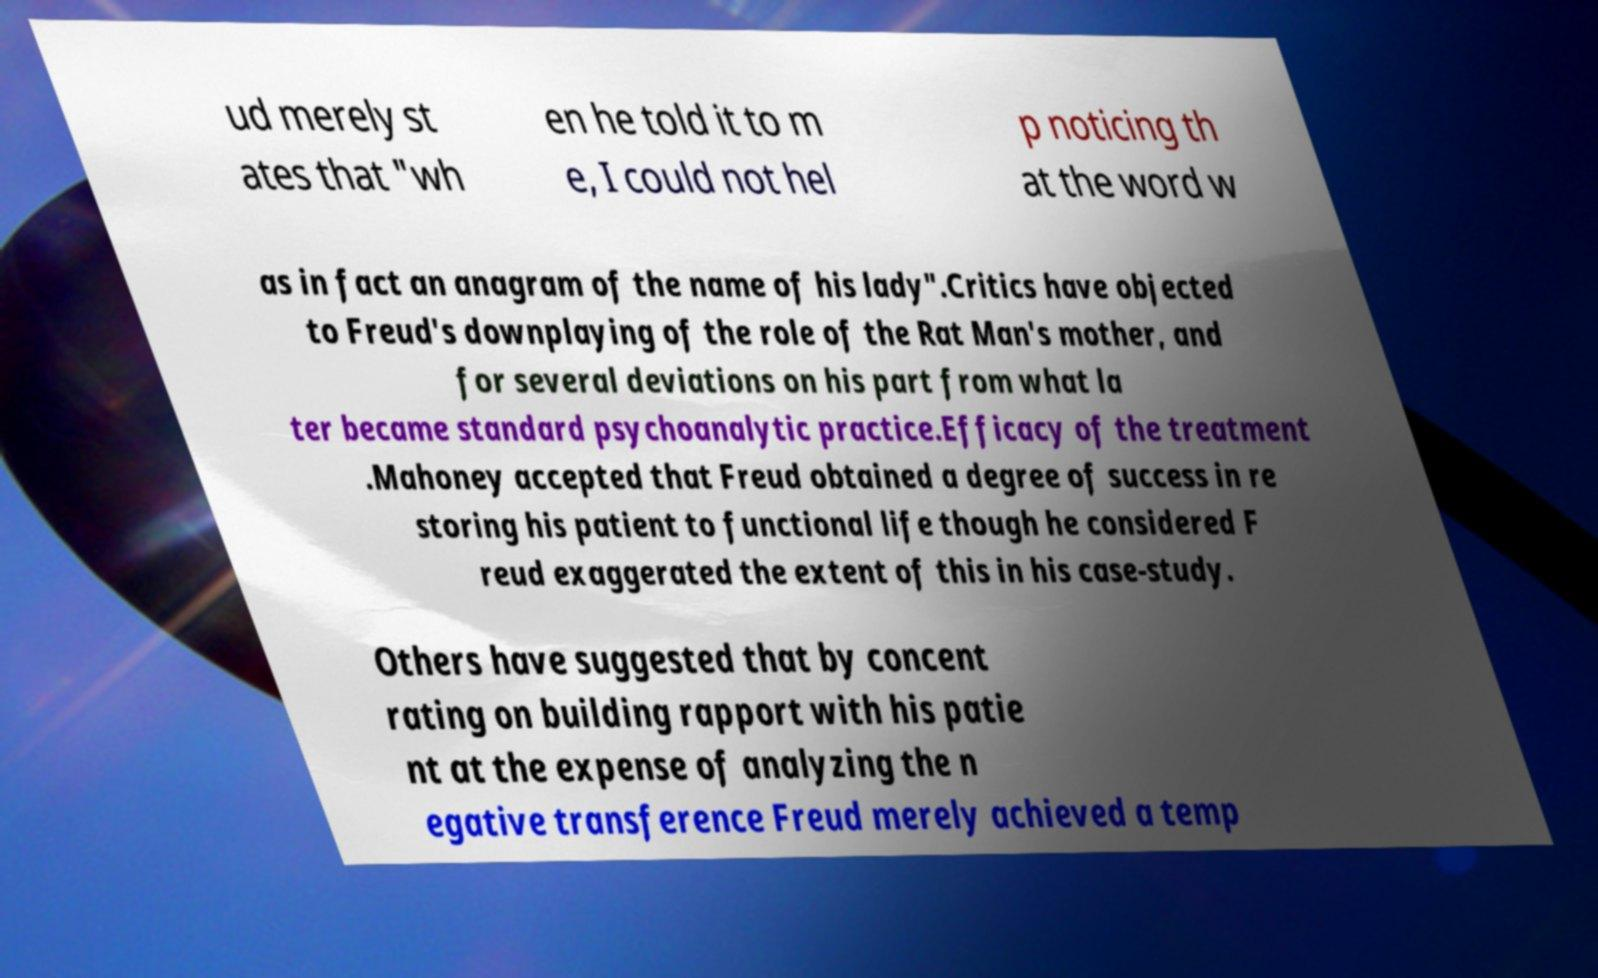Can you accurately transcribe the text from the provided image for me? ud merely st ates that "wh en he told it to m e, I could not hel p noticing th at the word w as in fact an anagram of the name of his lady".Critics have objected to Freud's downplaying of the role of the Rat Man's mother, and for several deviations on his part from what la ter became standard psychoanalytic practice.Efficacy of the treatment .Mahoney accepted that Freud obtained a degree of success in re storing his patient to functional life though he considered F reud exaggerated the extent of this in his case-study. Others have suggested that by concent rating on building rapport with his patie nt at the expense of analyzing the n egative transference Freud merely achieved a temp 